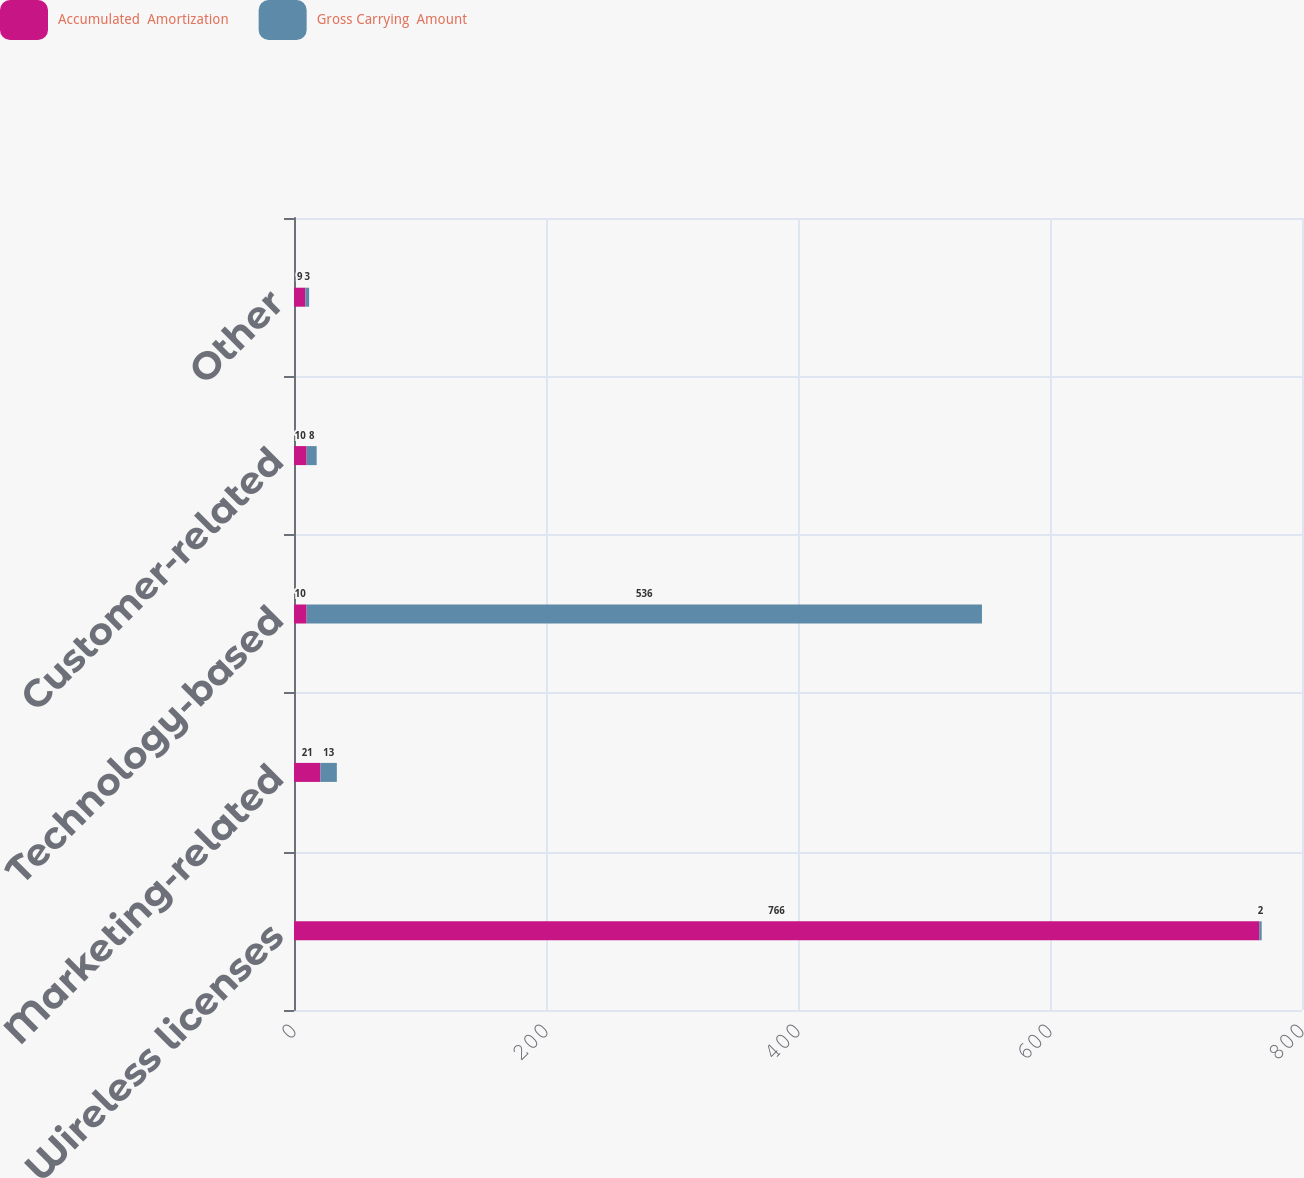Convert chart to OTSL. <chart><loc_0><loc_0><loc_500><loc_500><stacked_bar_chart><ecel><fcel>Wireless licenses<fcel>Marketing-related<fcel>Technology-based<fcel>Customer-related<fcel>Other<nl><fcel>Accumulated  Amortization<fcel>766<fcel>21<fcel>10<fcel>10<fcel>9<nl><fcel>Gross Carrying  Amount<fcel>2<fcel>13<fcel>536<fcel>8<fcel>3<nl></chart> 